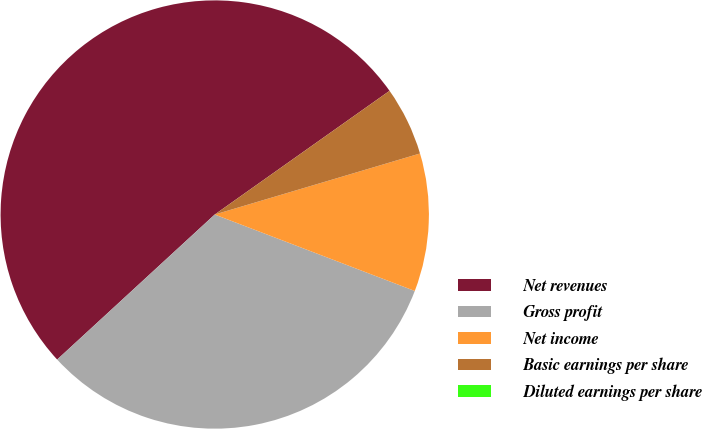<chart> <loc_0><loc_0><loc_500><loc_500><pie_chart><fcel>Net revenues<fcel>Gross profit<fcel>Net income<fcel>Basic earnings per share<fcel>Diluted earnings per share<nl><fcel>52.04%<fcel>32.35%<fcel>10.41%<fcel>5.2%<fcel>0.0%<nl></chart> 